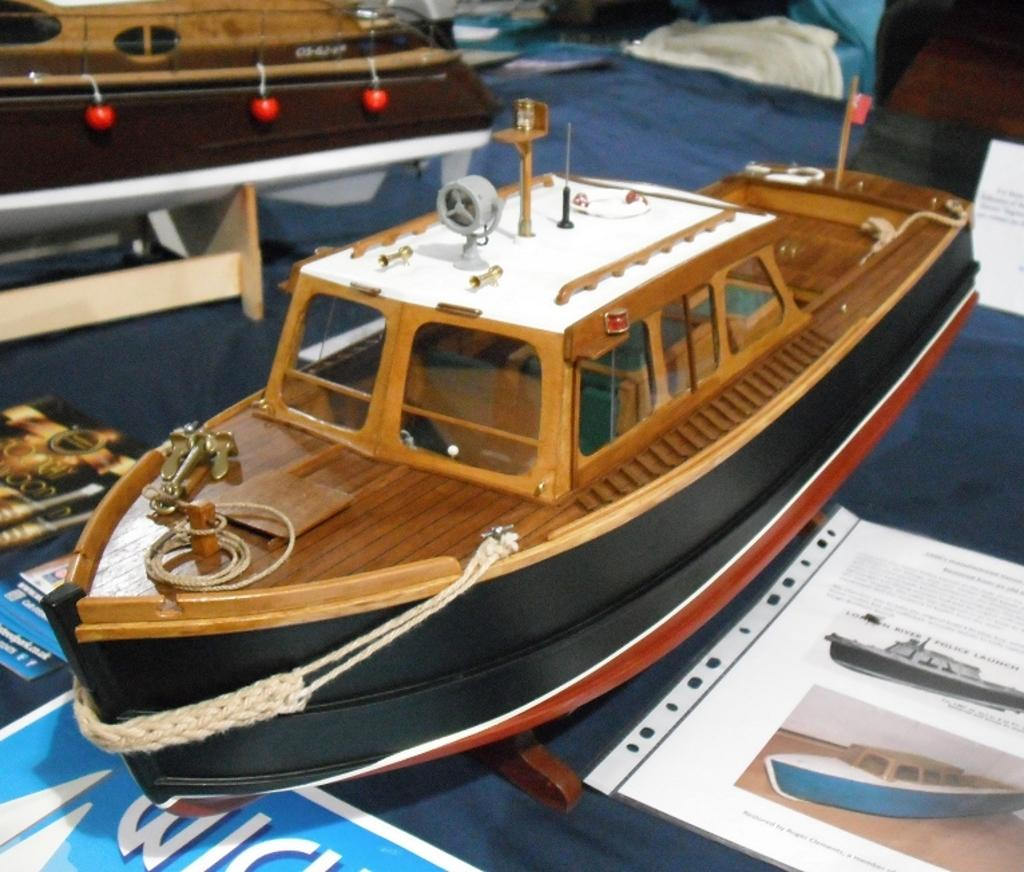What is located at the bottom of the image? There is a table at the bottom of the image. What objects are on the table? There are toy ships, a paper, and a book on the table. What level of thought is required to play with the toy ships in the image? The image does not provide information about the level of thought required to play with the toy ships, as it only shows their presence on the table. 